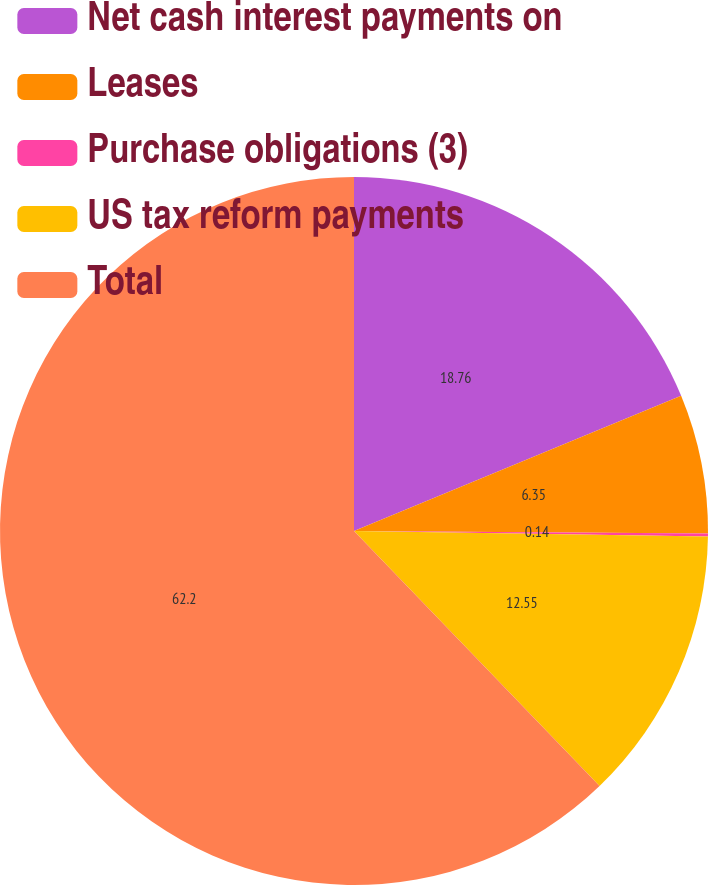<chart> <loc_0><loc_0><loc_500><loc_500><pie_chart><fcel>Net cash interest payments on<fcel>Leases<fcel>Purchase obligations (3)<fcel>US tax reform payments<fcel>Total<nl><fcel>18.76%<fcel>6.35%<fcel>0.14%<fcel>12.55%<fcel>62.2%<nl></chart> 